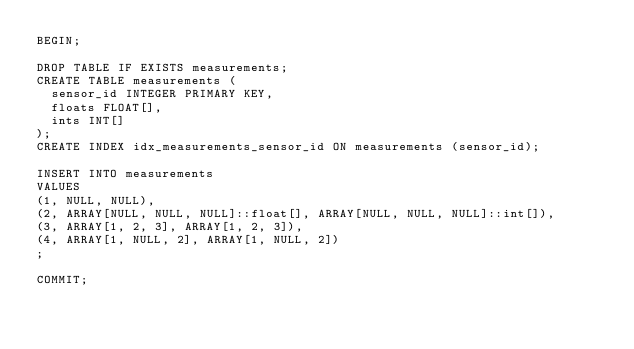<code> <loc_0><loc_0><loc_500><loc_500><_SQL_>BEGIN; 

DROP TABLE IF EXISTS measurements;
CREATE TABLE measurements (
  sensor_id INTEGER PRIMARY KEY,
  floats FLOAT[],
  ints INT[]
);
CREATE INDEX idx_measurements_sensor_id ON measurements (sensor_id);

INSERT INTO measurements
VALUES
(1, NULL, NULL),
(2, ARRAY[NULL, NULL, NULL]::float[], ARRAY[NULL, NULL, NULL]::int[]),
(3, ARRAY[1, 2, 3], ARRAY[1, 2, 3]),
(4, ARRAY[1, NULL, 2], ARRAY[1, NULL, 2])
;

COMMIT;
</code> 